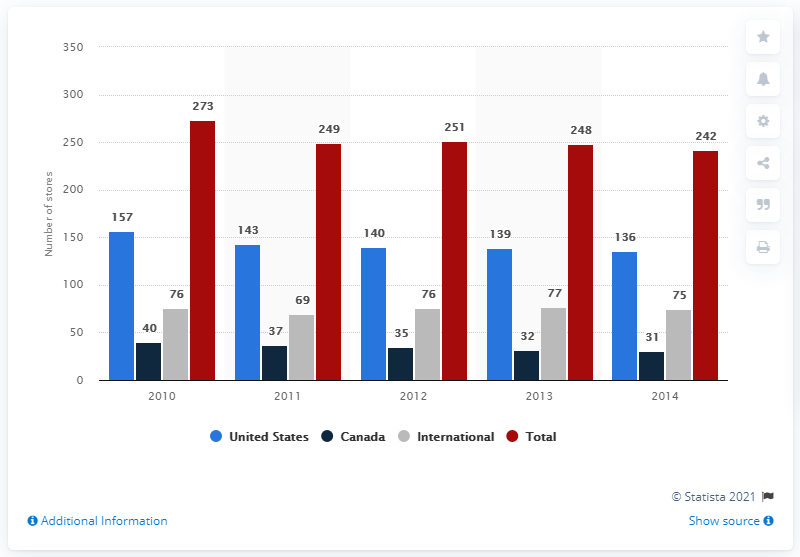Highlight a few significant elements in this photo. By the end of the 2011 fiscal year, American Apparel operated 249 stores. In the year 2010, Canada had the highest number of American Apparel stores. In all years combined, the total number of United States apparel products is 715. 